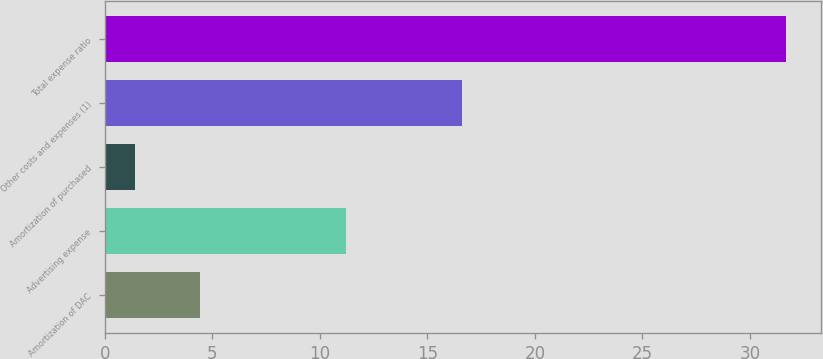Convert chart to OTSL. <chart><loc_0><loc_0><loc_500><loc_500><bar_chart><fcel>Amortization of DAC<fcel>Advertising expense<fcel>Amortization of purchased<fcel>Other costs and expenses (1)<fcel>Total expense ratio<nl><fcel>4.43<fcel>11.2<fcel>1.4<fcel>16.6<fcel>31.7<nl></chart> 